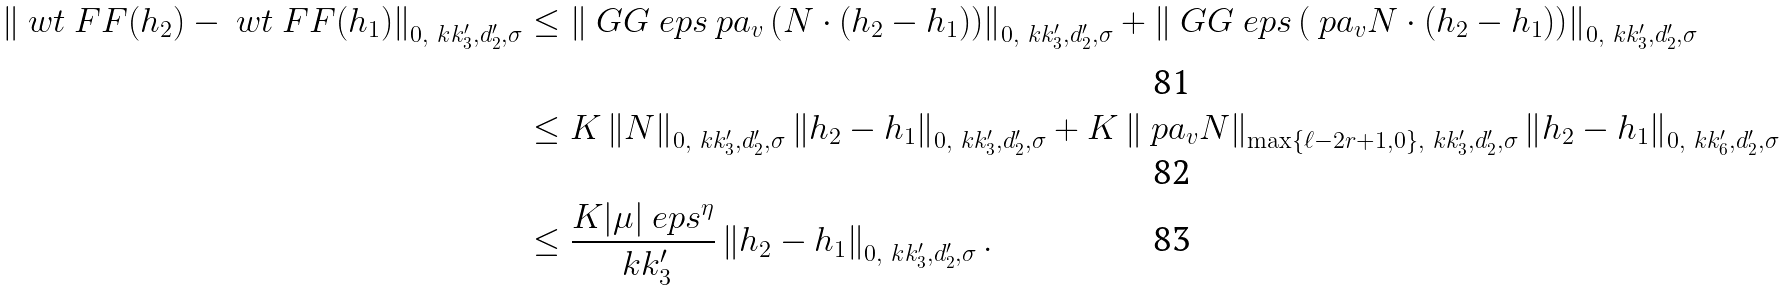<formula> <loc_0><loc_0><loc_500><loc_500>\left \| \ w t \ F F ( h _ { 2 } ) - \ w t \ F F ( h _ { 1 } ) \right \| _ { 0 , \ k k _ { 3 } ^ { \prime } , d _ { 2 } ^ { \prime } , \sigma } & \leq \left \| \ G G _ { \ } e p s \ p a _ { v } \left ( N \cdot ( h _ { 2 } - h _ { 1 } ) \right ) \right \| _ { 0 , \ k k _ { 3 } ^ { \prime } , d _ { 2 } ^ { \prime } , \sigma } + \left \| \ G G _ { \ } e p s \left ( \ p a _ { v } N \cdot ( h _ { 2 } - h _ { 1 } ) \right ) \right \| _ { 0 , \ k k _ { 3 } ^ { \prime } , d _ { 2 } ^ { \prime } , \sigma } \\ & \leq K \left \| N \right \| _ { 0 , \ k k _ { 3 } ^ { \prime } , d _ { 2 } ^ { \prime } , \sigma } \left \| h _ { 2 } - h _ { 1 } \right \| _ { 0 , \ k k _ { 3 } ^ { \prime } , d _ { 2 } ^ { \prime } , \sigma } + K \left \| \ p a _ { v } N \right \| _ { \max \{ \ell - 2 r + 1 , 0 \} , \ k k _ { 3 } ^ { \prime } , d _ { 2 } ^ { \prime } , \sigma } \left \| h _ { 2 } - h _ { 1 } \right \| _ { 0 , \ k k _ { 6 } ^ { \prime } , d _ { 2 } ^ { \prime } , \sigma } \\ & \leq \frac { K | \mu | \ e p s ^ { \eta } } { \ k k _ { 3 } ^ { \prime } } \left \| h _ { 2 } - h _ { 1 } \right \| _ { 0 , \ k k _ { 3 } ^ { \prime } , d _ { 2 } ^ { \prime } , \sigma } .</formula> 